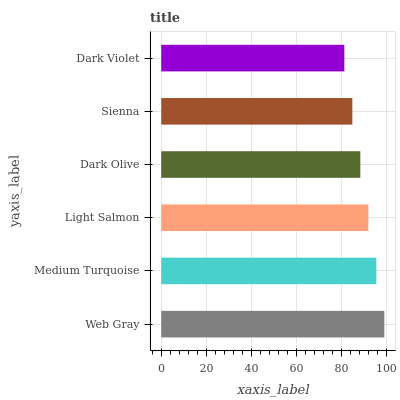Is Dark Violet the minimum?
Answer yes or no. Yes. Is Web Gray the maximum?
Answer yes or no. Yes. Is Medium Turquoise the minimum?
Answer yes or no. No. Is Medium Turquoise the maximum?
Answer yes or no. No. Is Web Gray greater than Medium Turquoise?
Answer yes or no. Yes. Is Medium Turquoise less than Web Gray?
Answer yes or no. Yes. Is Medium Turquoise greater than Web Gray?
Answer yes or no. No. Is Web Gray less than Medium Turquoise?
Answer yes or no. No. Is Light Salmon the high median?
Answer yes or no. Yes. Is Dark Olive the low median?
Answer yes or no. Yes. Is Medium Turquoise the high median?
Answer yes or no. No. Is Sienna the low median?
Answer yes or no. No. 